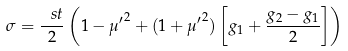<formula> <loc_0><loc_0><loc_500><loc_500>\sigma = \frac { \ s t } { 2 } \left ( 1 - { \mu ^ { \prime } } ^ { 2 } + ( 1 + { \mu ^ { \prime } } ^ { 2 } ) \left [ g _ { 1 } + \frac { g _ { 2 } - g _ { 1 } } { 2 } \right ] \right )</formula> 